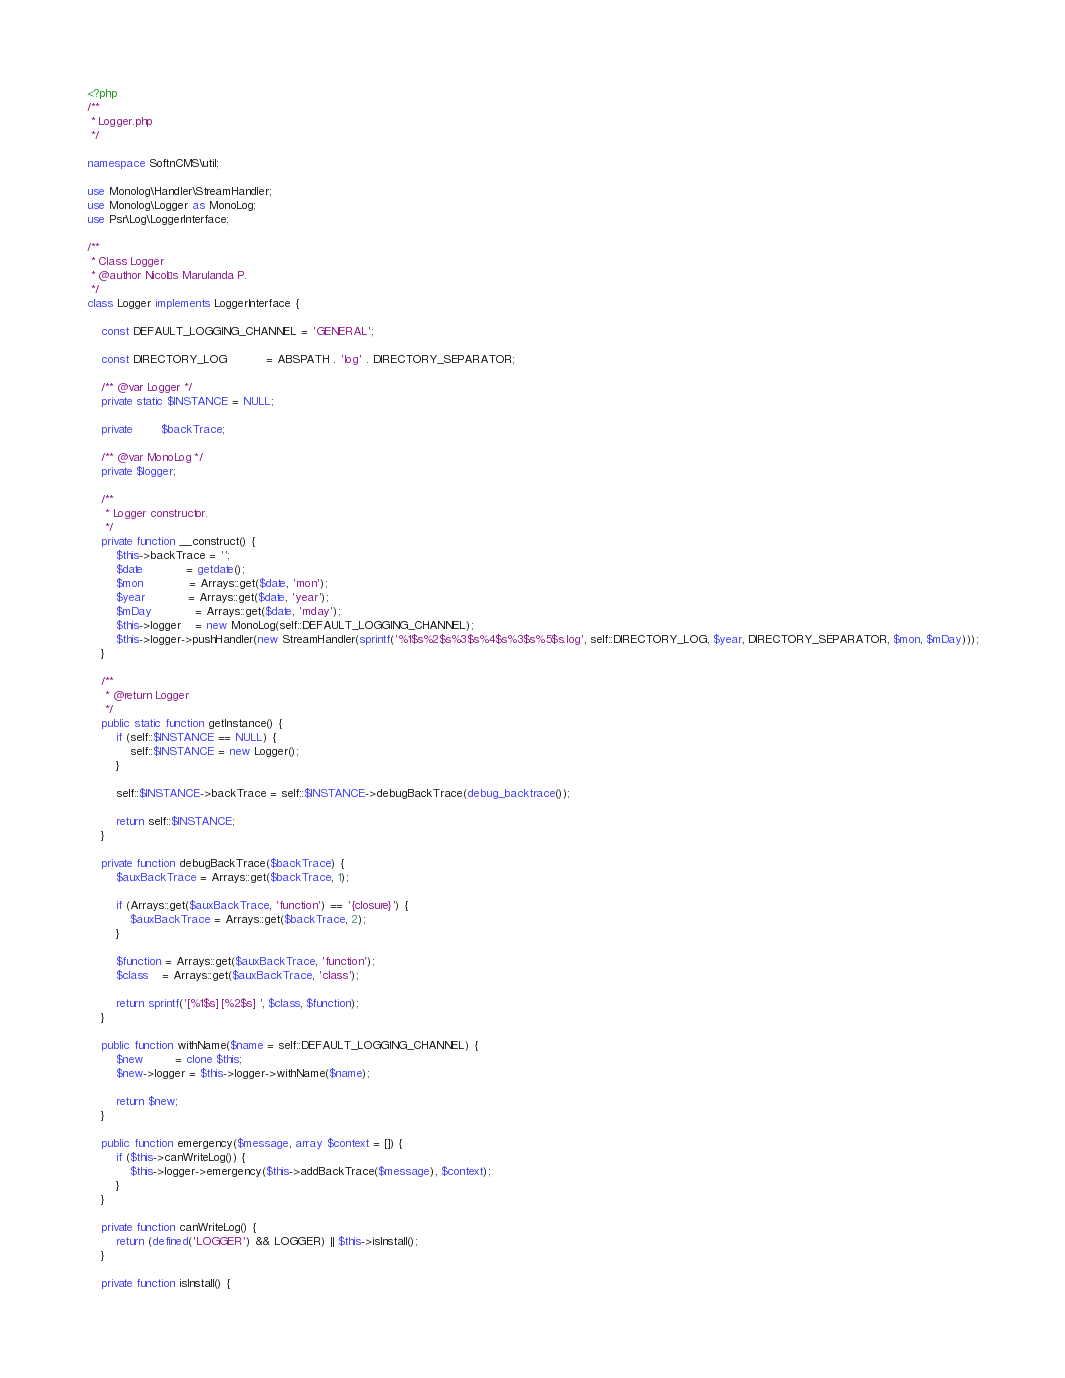Convert code to text. <code><loc_0><loc_0><loc_500><loc_500><_PHP_><?php
/**
 * Logger.php
 */

namespace SoftnCMS\util;

use Monolog\Handler\StreamHandler;
use Monolog\Logger as MonoLog;
use Psr\Log\LoggerInterface;

/**
 * Class Logger
 * @author Nicolás Marulanda P.
 */
class Logger implements LoggerInterface {
    
    const DEFAULT_LOGGING_CHANNEL = 'GENERAL';
    
    const DIRECTORY_LOG           = ABSPATH . 'log' . DIRECTORY_SEPARATOR;
    
    /** @var Logger */
    private static $INSTANCE = NULL;
    
    private        $backTrace;
    
    /** @var MonoLog */
    private $logger;
    
    /**
     * Logger constructor.
     */
    private function __construct() {
        $this->backTrace = '';
        $date            = getdate();
        $mon             = Arrays::get($date, 'mon');
        $year            = Arrays::get($date, 'year');
        $mDay            = Arrays::get($date, 'mday');
        $this->logger    = new MonoLog(self::DEFAULT_LOGGING_CHANNEL);
        $this->logger->pushHandler(new StreamHandler(sprintf('%1$s%2$s%3$s%4$s%3$s%5$s.log', self::DIRECTORY_LOG, $year, DIRECTORY_SEPARATOR, $mon, $mDay)));
    }
    
    /**
     * @return Logger
     */
    public static function getInstance() {
        if (self::$INSTANCE == NULL) {
            self::$INSTANCE = new Logger();
        }
        
        self::$INSTANCE->backTrace = self::$INSTANCE->debugBackTrace(debug_backtrace());
        
        return self::$INSTANCE;
    }
    
    private function debugBackTrace($backTrace) {
        $auxBackTrace = Arrays::get($backTrace, 1);
        
        if (Arrays::get($auxBackTrace, 'function') == '{closure}') {
            $auxBackTrace = Arrays::get($backTrace, 2);
        }
        
        $function = Arrays::get($auxBackTrace, 'function');
        $class    = Arrays::get($auxBackTrace, 'class');
        
        return sprintf('[%1$s] [%2$s] ', $class, $function);
    }
    
    public function withName($name = self::DEFAULT_LOGGING_CHANNEL) {
        $new         = clone $this;
        $new->logger = $this->logger->withName($name);
        
        return $new;
    }
    
    public function emergency($message, array $context = []) {
        if ($this->canWriteLog()) {
            $this->logger->emergency($this->addBackTrace($message), $context);
        }
    }
    
    private function canWriteLog() {
        return (defined('LOGGER') && LOGGER) || $this->isInstall();
    }
    
    private function isInstall() {</code> 